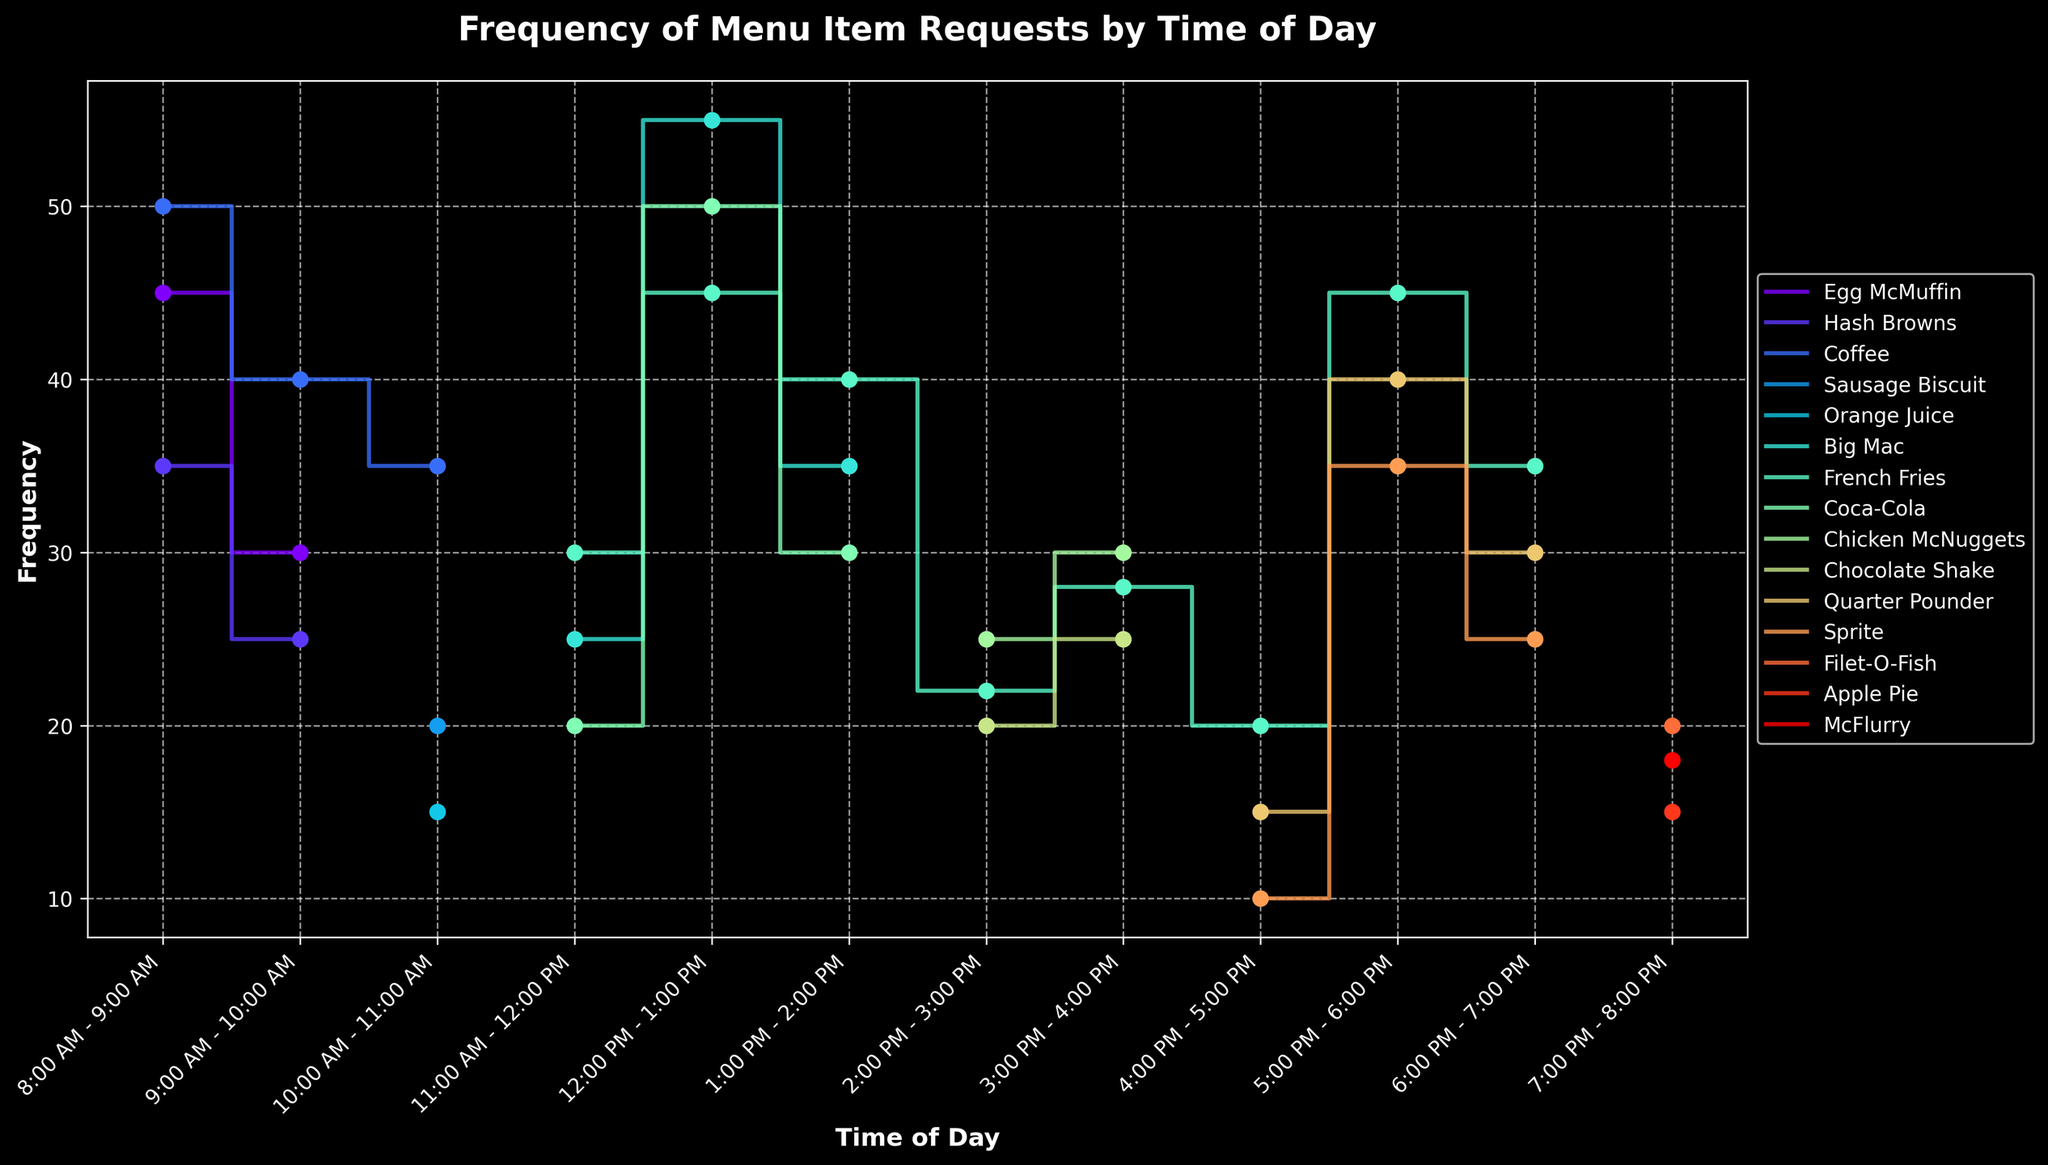What is the title of the plot? The title of the plot is usually presented near the top center of the figure. Look at the top of the figure to find the text describing the overarching topic.
Answer: Frequency of Menu Item Requests by Time of Day Which item is most frequently requested between 8:00 AM - 9:00 AM? To determine the most requested item, look at the frequency values for 8:00 AM - 9:00 AM. Compare the values for Egg McMuffin, Hash Browns, and Coffee.
Answer: Coffee How does the frequency of Big Mac requests change from 11:00 AM - 12:00 PM to 12:00 PM - 1:00 PM? Observe the values for Big Mac requests at the respective times. Note the frequency at 11:00 AM - 12:00 PM and then at 12:00 PM - 1:00 PM. Calculate the difference.
Answer: It increases from 25 to 55 What is the highest frequency of requests observed for French Fries? To find this, check the frequency values for French Fries across all time intervals and pick the highest one.
Answer: 45 During which time periods are Coca-Cola requests observed? Scan the time intervals and look for those that include Coca-Cola. List all those intervals.
Answer: 11:00 AM - 12:00 PM, 12:00 PM - 1:00 PM, 1:00 PM - 2:00 PM Between 9:00 AM - 10:00 AM and 10:00 AM - 11:00 AM, which item shows a rising trend in frequency? Compare the frequency values for each item between these two time periods. Identify the item that has an increasing frequency.
Answer: Coffee What is the average frequency of Coffee requests from 8:00 AM to 11:00 AM? Sum the frequency values of Coffee from 8:00 AM - 9:00 AM, 9:00 AM - 10:00 AM, and 10:00 AM - 11:00 AM, then divide by the number of intervals.
Answer: (50 + 40 + 35)/3 = 41.67 Which time interval has the lowest frequency for Sprite requests? Examine the frequency values for Sprite across all time intervals and identify the smallest one.
Answer: 4:00 PM - 5:00 PM How does the frequency of requests for French Fries compare between 2:00 PM - 3:00 PM and 3:00 PM - 4:00 PM? Look at the frequency values for French Fries in these two time periods and compare them to see which is higher or if they are equal.
Answer: It increases from 22 to 28 What is the combined frequency of Muffin and Biscuit requests between 8:00 AM and 11:00 AM? Add the frequencies for Egg McMuffin from 8:00 AM - 9:00 AM and 9:00 AM - 10:00 AM, and for Sausage Biscuit from 10:00 AM - 11:00 AM.
Answer: 45 + 30 + 20 = 95 